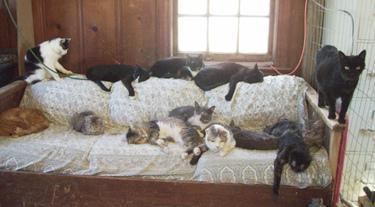What is the paneling made of which is covering the walls?
Indicate the correct response and explain using: 'Answer: answer
Rationale: rationale.'
Options: Cedar, oak, birch, pine. Answer: pine.
Rationale: The paneling is made of pine. 